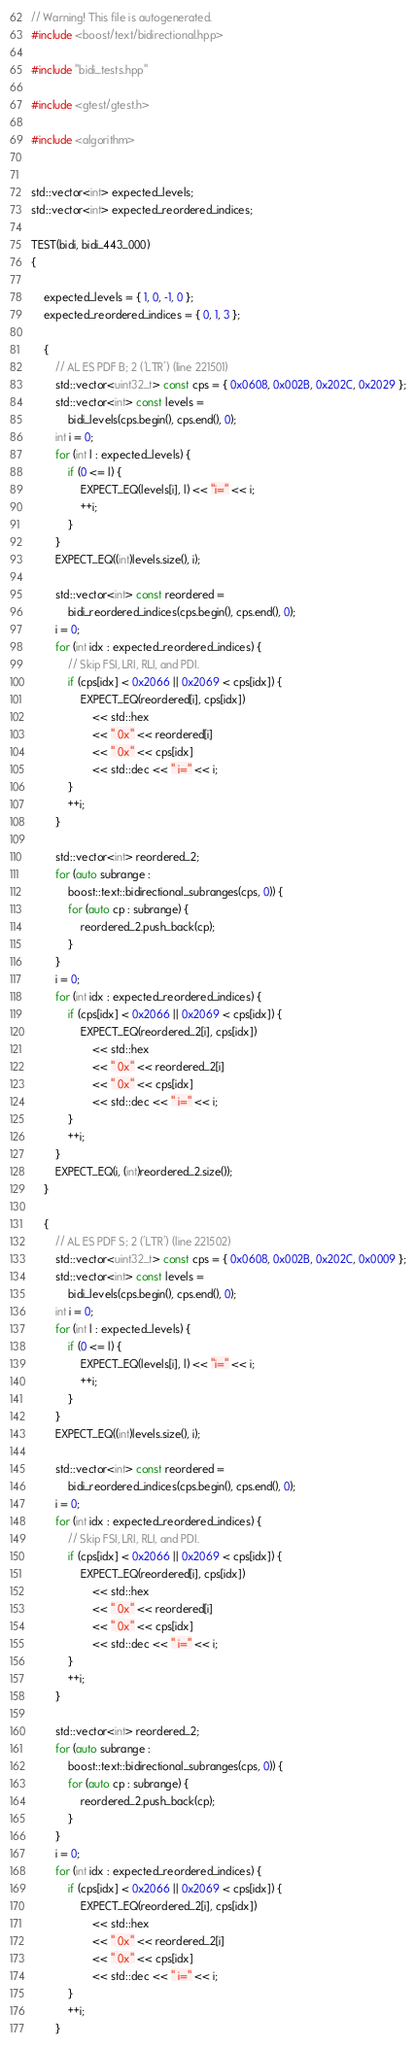<code> <loc_0><loc_0><loc_500><loc_500><_C++_>// Warning! This file is autogenerated.
#include <boost/text/bidirectional.hpp>

#include "bidi_tests.hpp"

#include <gtest/gtest.h>

#include <algorithm>


std::vector<int> expected_levels;
std::vector<int> expected_reordered_indices;

TEST(bidi, bidi_443_000)
{

    expected_levels = { 1, 0, -1, 0 };
    expected_reordered_indices = { 0, 1, 3 };

    {
        // AL ES PDF B; 2 ('LTR') (line 221501)
        std::vector<uint32_t> const cps = { 0x0608, 0x002B, 0x202C, 0x2029 };
        std::vector<int> const levels =
            bidi_levels(cps.begin(), cps.end(), 0);
        int i = 0;
        for (int l : expected_levels) {
            if (0 <= l) {
                EXPECT_EQ(levels[i], l) << "i=" << i;
                ++i;
            }
        }
        EXPECT_EQ((int)levels.size(), i);

        std::vector<int> const reordered =
            bidi_reordered_indices(cps.begin(), cps.end(), 0);
        i = 0;
        for (int idx : expected_reordered_indices) {
            // Skip FSI, LRI, RLI, and PDI.
            if (cps[idx] < 0x2066 || 0x2069 < cps[idx]) {
                EXPECT_EQ(reordered[i], cps[idx])
                    << std::hex
                    << " 0x" << reordered[i]
                    << " 0x" << cps[idx]
                    << std::dec << " i=" << i;
            }
            ++i;
        }

        std::vector<int> reordered_2;
        for (auto subrange :
            boost::text::bidirectional_subranges(cps, 0)) {
            for (auto cp : subrange) {
                reordered_2.push_back(cp);
            }
        }
        i = 0;
        for (int idx : expected_reordered_indices) {
            if (cps[idx] < 0x2066 || 0x2069 < cps[idx]) {
                EXPECT_EQ(reordered_2[i], cps[idx])
                    << std::hex
                    << " 0x" << reordered_2[i]
                    << " 0x" << cps[idx]
                    << std::dec << " i=" << i;
            }
            ++i;
        }
        EXPECT_EQ(i, (int)reordered_2.size());
    }

    {
        // AL ES PDF S; 2 ('LTR') (line 221502)
        std::vector<uint32_t> const cps = { 0x0608, 0x002B, 0x202C, 0x0009 };
        std::vector<int> const levels =
            bidi_levels(cps.begin(), cps.end(), 0);
        int i = 0;
        for (int l : expected_levels) {
            if (0 <= l) {
                EXPECT_EQ(levels[i], l) << "i=" << i;
                ++i;
            }
        }
        EXPECT_EQ((int)levels.size(), i);

        std::vector<int> const reordered =
            bidi_reordered_indices(cps.begin(), cps.end(), 0);
        i = 0;
        for (int idx : expected_reordered_indices) {
            // Skip FSI, LRI, RLI, and PDI.
            if (cps[idx] < 0x2066 || 0x2069 < cps[idx]) {
                EXPECT_EQ(reordered[i], cps[idx])
                    << std::hex
                    << " 0x" << reordered[i]
                    << " 0x" << cps[idx]
                    << std::dec << " i=" << i;
            }
            ++i;
        }

        std::vector<int> reordered_2;
        for (auto subrange :
            boost::text::bidirectional_subranges(cps, 0)) {
            for (auto cp : subrange) {
                reordered_2.push_back(cp);
            }
        }
        i = 0;
        for (int idx : expected_reordered_indices) {
            if (cps[idx] < 0x2066 || 0x2069 < cps[idx]) {
                EXPECT_EQ(reordered_2[i], cps[idx])
                    << std::hex
                    << " 0x" << reordered_2[i]
                    << " 0x" << cps[idx]
                    << std::dec << " i=" << i;
            }
            ++i;
        }</code> 